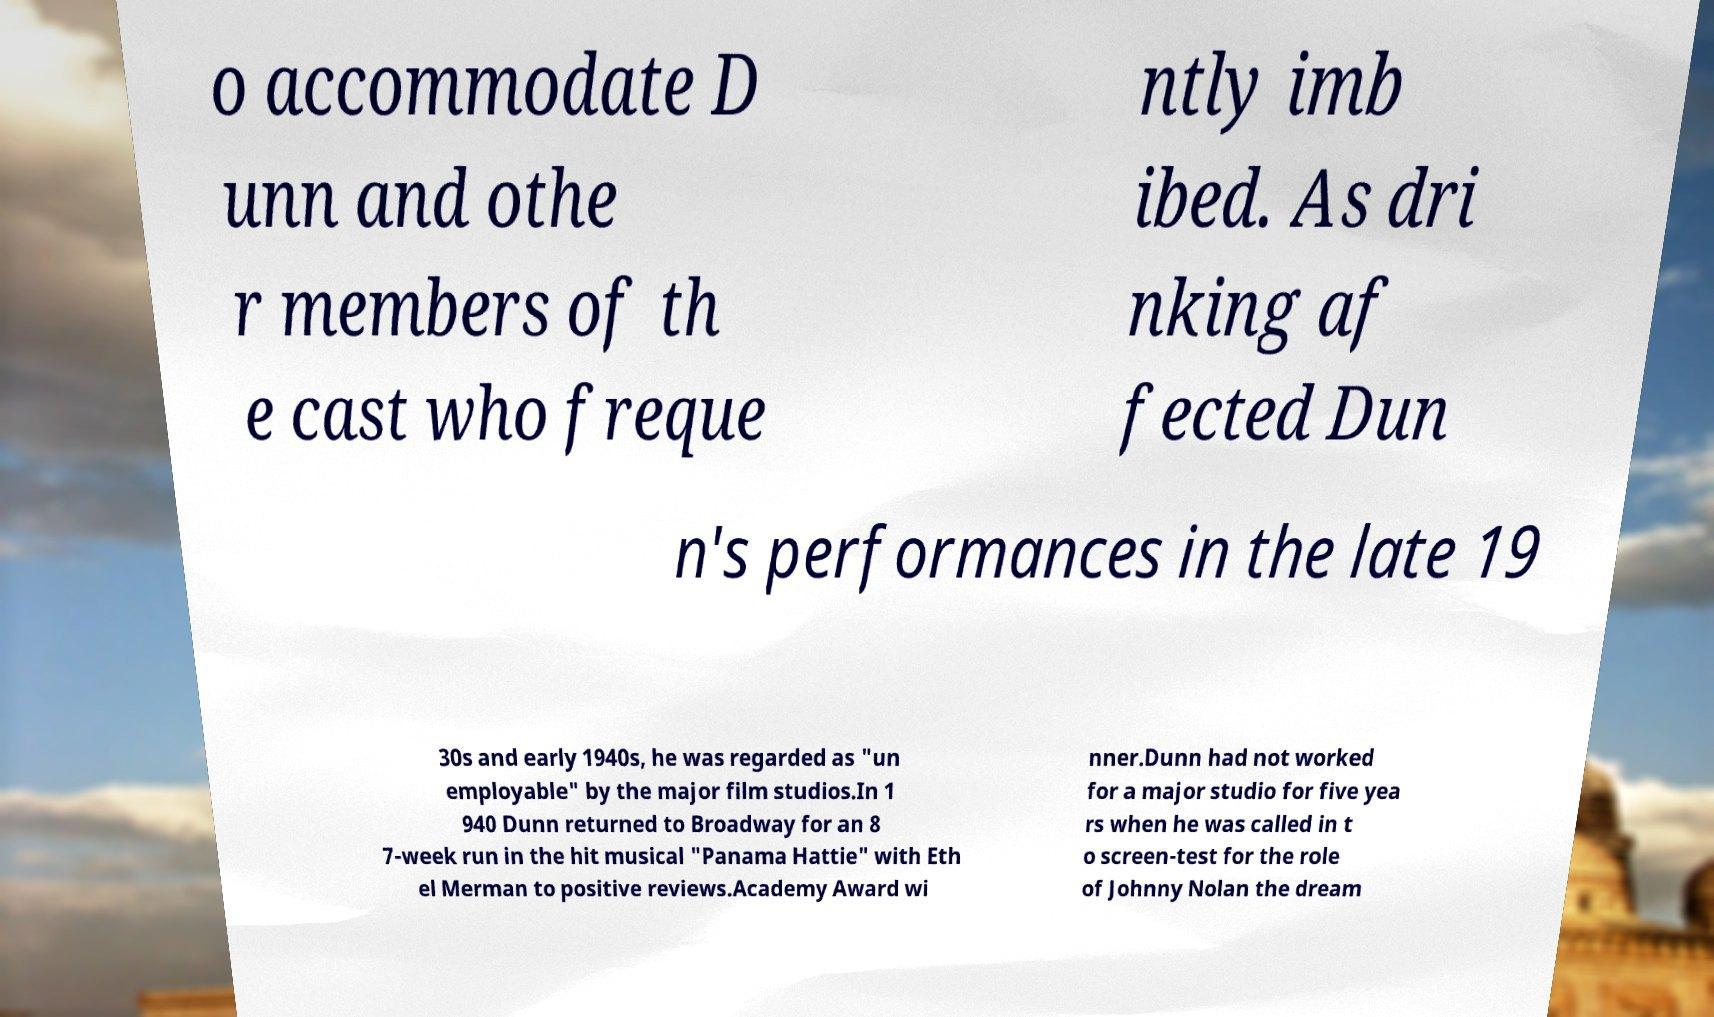Could you assist in decoding the text presented in this image and type it out clearly? o accommodate D unn and othe r members of th e cast who freque ntly imb ibed. As dri nking af fected Dun n's performances in the late 19 30s and early 1940s, he was regarded as "un employable" by the major film studios.In 1 940 Dunn returned to Broadway for an 8 7-week run in the hit musical "Panama Hattie" with Eth el Merman to positive reviews.Academy Award wi nner.Dunn had not worked for a major studio for five yea rs when he was called in t o screen-test for the role of Johnny Nolan the dream 